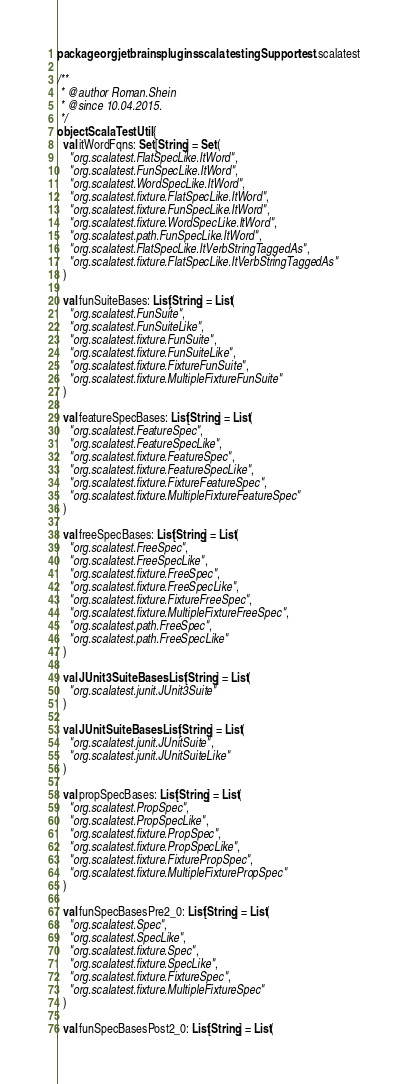<code> <loc_0><loc_0><loc_500><loc_500><_Scala_>package org.jetbrains.plugins.scala.testingSupport.test.scalatest

/**
 * @author Roman.Shein
 * @since 10.04.2015.
 */
object ScalaTestUtil {
  val itWordFqns: Set[String] = Set(
    "org.scalatest.FlatSpecLike.ItWord",
    "org.scalatest.FunSpecLike.ItWord",
    "org.scalatest.WordSpecLike.ItWord",
    "org.scalatest.fixture.FlatSpecLike.ItWord",
    "org.scalatest.fixture.FunSpecLike.ItWord",
    "org.scalatest.fixture.WordSpecLike.ItWord",
    "org.scalatest.path.FunSpecLike.ItWord",
    "org.scalatest.FlatSpecLike.ItVerbStringTaggedAs",
    "org.scalatest.fixture.FlatSpecLike.ItVerbStringTaggedAs"
  )

  val funSuiteBases: List[String] = List(
    "org.scalatest.FunSuite",
    "org.scalatest.FunSuiteLike",
    "org.scalatest.fixture.FunSuite",
    "org.scalatest.fixture.FunSuiteLike",
    "org.scalatest.fixture.FixtureFunSuite",
    "org.scalatest.fixture.MultipleFixtureFunSuite"
  )

  val featureSpecBases: List[String] = List(
    "org.scalatest.FeatureSpec",
    "org.scalatest.FeatureSpecLike",
    "org.scalatest.fixture.FeatureSpec",
    "org.scalatest.fixture.FeatureSpecLike",
    "org.scalatest.fixture.FixtureFeatureSpec",
    "org.scalatest.fixture.MultipleFixtureFeatureSpec"
  )

  val freeSpecBases: List[String] = List(
    "org.scalatest.FreeSpec",
    "org.scalatest.FreeSpecLike",
    "org.scalatest.fixture.FreeSpec",
    "org.scalatest.fixture.FreeSpecLike",
    "org.scalatest.fixture.FixtureFreeSpec",
    "org.scalatest.fixture.MultipleFixtureFreeSpec",
    "org.scalatest.path.FreeSpec",
    "org.scalatest.path.FreeSpecLike"
  )

  val JUnit3SuiteBases: List[String] = List(
    "org.scalatest.junit.JUnit3Suite"
  )

  val JUnitSuiteBases: List[String] = List(
    "org.scalatest.junit.JUnitSuite",
    "org.scalatest.junit.JUnitSuiteLike"
  )

  val propSpecBases: List[String] = List(
    "org.scalatest.PropSpec",
    "org.scalatest.PropSpecLike",
    "org.scalatest.fixture.PropSpec",
    "org.scalatest.fixture.PropSpecLike",
    "org.scalatest.fixture.FixturePropSpec",
    "org.scalatest.fixture.MultipleFixturePropSpec"
  )

  val funSpecBasesPre2_0: List[String] = List(
    "org.scalatest.Spec",
    "org.scalatest.SpecLike",
    "org.scalatest.fixture.Spec",
    "org.scalatest.fixture.SpecLike",
    "org.scalatest.fixture.FixtureSpec",
    "org.scalatest.fixture.MultipleFixtureSpec"
  )

  val funSpecBasesPost2_0: List[String] = List(</code> 